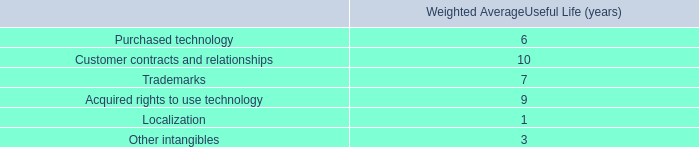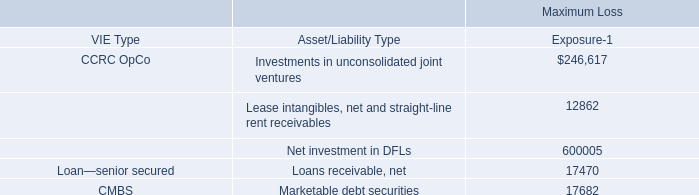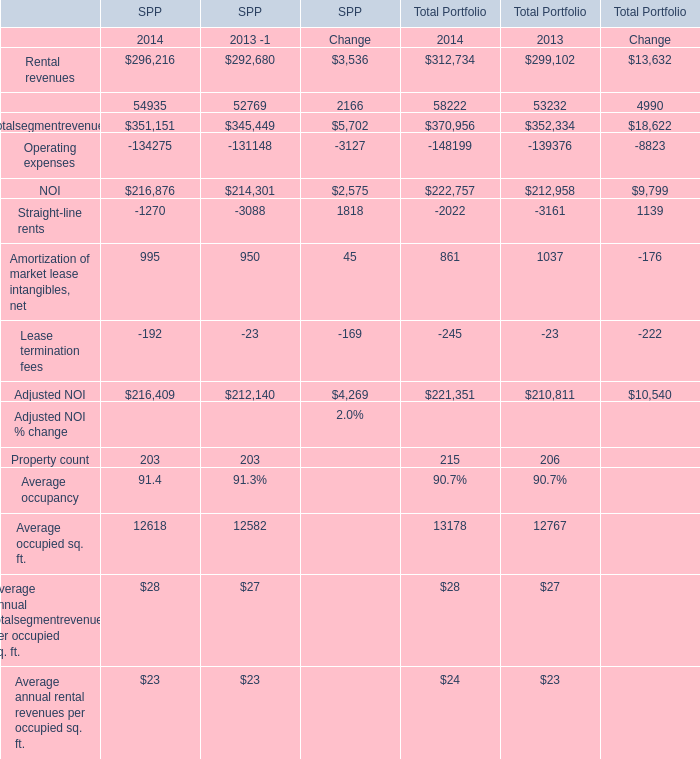What's the growth rate of NOI of total portfolio in 2014? 
Computations: ((222757 - 212958) / 212958)
Answer: 0.04601. 